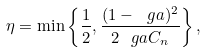Convert formula to latex. <formula><loc_0><loc_0><loc_500><loc_500>\eta = \min \left \{ \frac { 1 } { 2 } , \frac { ( 1 - \ g a ) ^ { 2 } } { 2 \ g a C _ { n } } \right \} ,</formula> 